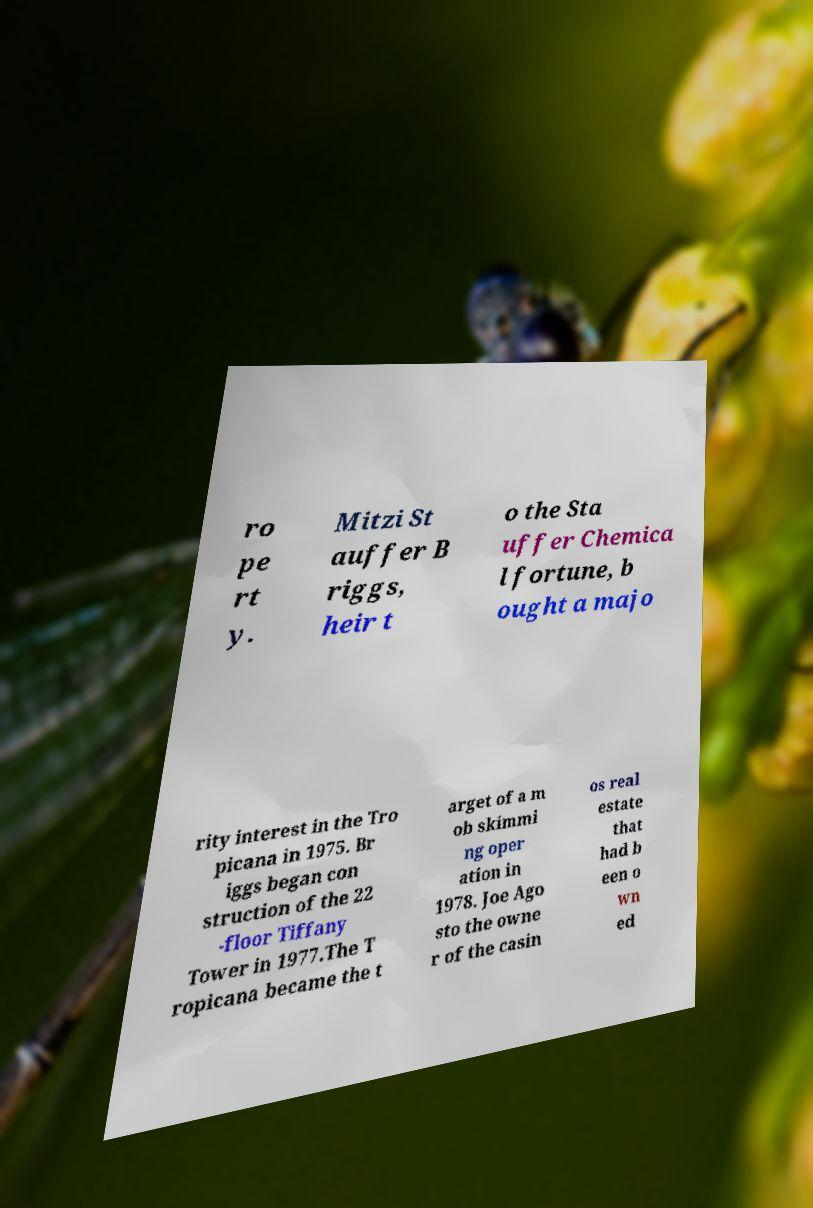I need the written content from this picture converted into text. Can you do that? ro pe rt y. Mitzi St auffer B riggs, heir t o the Sta uffer Chemica l fortune, b ought a majo rity interest in the Tro picana in 1975. Br iggs began con struction of the 22 -floor Tiffany Tower in 1977.The T ropicana became the t arget of a m ob skimmi ng oper ation in 1978. Joe Ago sto the owne r of the casin os real estate that had b een o wn ed 